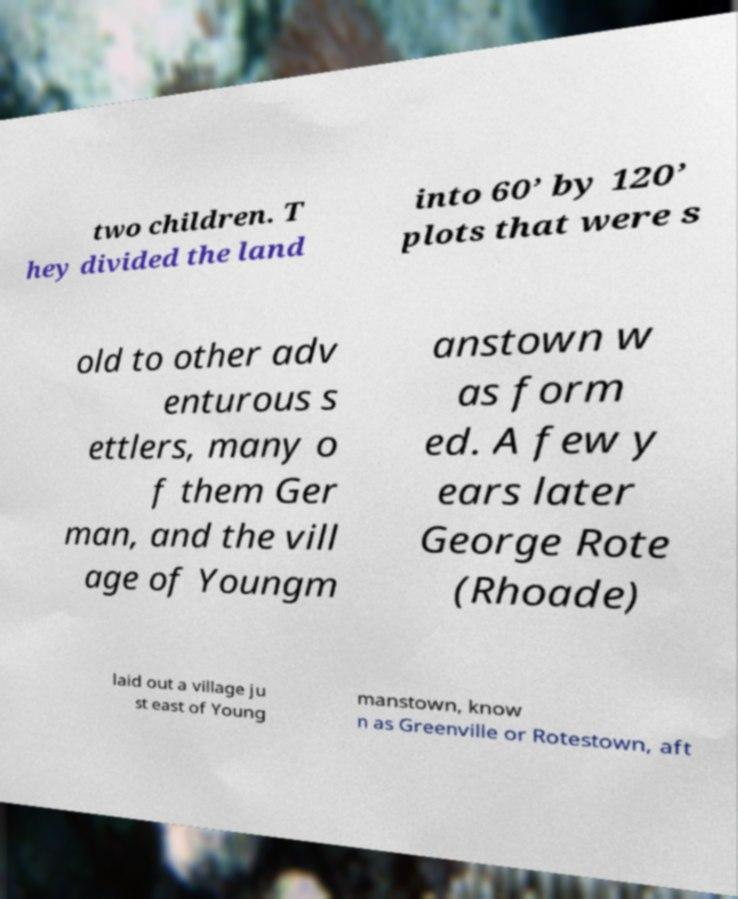Can you read and provide the text displayed in the image?This photo seems to have some interesting text. Can you extract and type it out for me? two children. T hey divided the land into 60’ by 120’ plots that were s old to other adv enturous s ettlers, many o f them Ger man, and the vill age of Youngm anstown w as form ed. A few y ears later George Rote (Rhoade) laid out a village ju st east of Young manstown, know n as Greenville or Rotestown, aft 